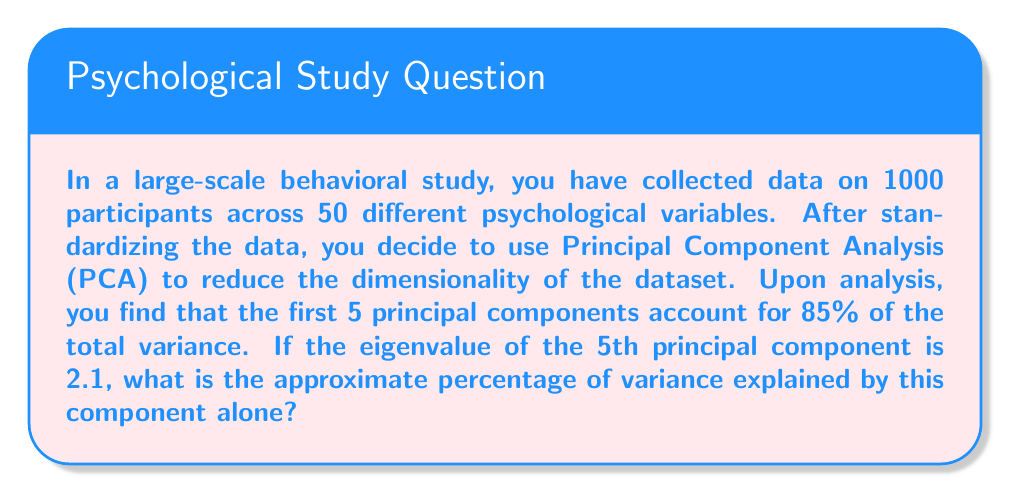Teach me how to tackle this problem. To solve this problem, we need to understand the relationship between eigenvalues and explained variance in PCA. Let's break it down step-by-step:

1. In PCA, each principal component is associated with an eigenvalue that represents the amount of variance explained by that component.

2. The total variance in a standardized dataset is equal to the number of variables. In this case:
   Total variance = 50 (since there are 50 variables)

3. The proportion of variance explained by a single component is calculated by dividing its eigenvalue by the total variance:

   $$ \text{Proportion of variance} = \frac{\text{Eigenvalue}}{\text{Total variance}} $$

4. We are given that the eigenvalue of the 5th principal component is 2.1. Let's plug this into our equation:

   $$ \text{Proportion of variance} = \frac{2.1}{50} = 0.042 $$

5. To express this as a percentage, we multiply by 100:

   $$ \text{Percentage of variance} = 0.042 \times 100 = 4.2\% $$

Therefore, the 5th principal component explains approximately 4.2% of the total variance in the dataset.
Answer: 4.2% 